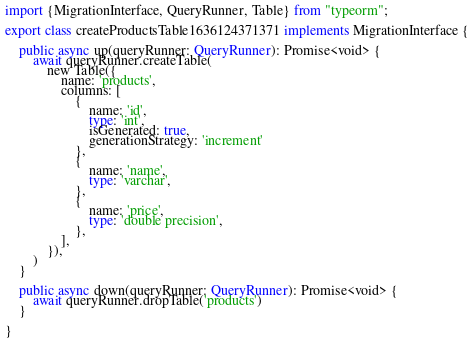Convert code to text. <code><loc_0><loc_0><loc_500><loc_500><_TypeScript_>import {MigrationInterface, QueryRunner, Table} from "typeorm";

export class createProductsTable1636124371371 implements MigrationInterface {

    public async up(queryRunner: QueryRunner): Promise<void> {
        await queryRunner.createTable(
            new Table({
                name: 'products',
                columns: [
                    {
                        name: 'id',
                        type: 'int',
                        isGenerated: true,
                        generationStrategy: 'increment'
                    },
                    {
                        name: 'name',
                        type: 'varchar',
                    },
                    {
                        name: 'price',
                        type: 'double precision',
                    },
                ],
            }),
        )
    }

    public async down(queryRunner: QueryRunner): Promise<void> {
        await queryRunner.dropTable('products')
    }

}
</code> 